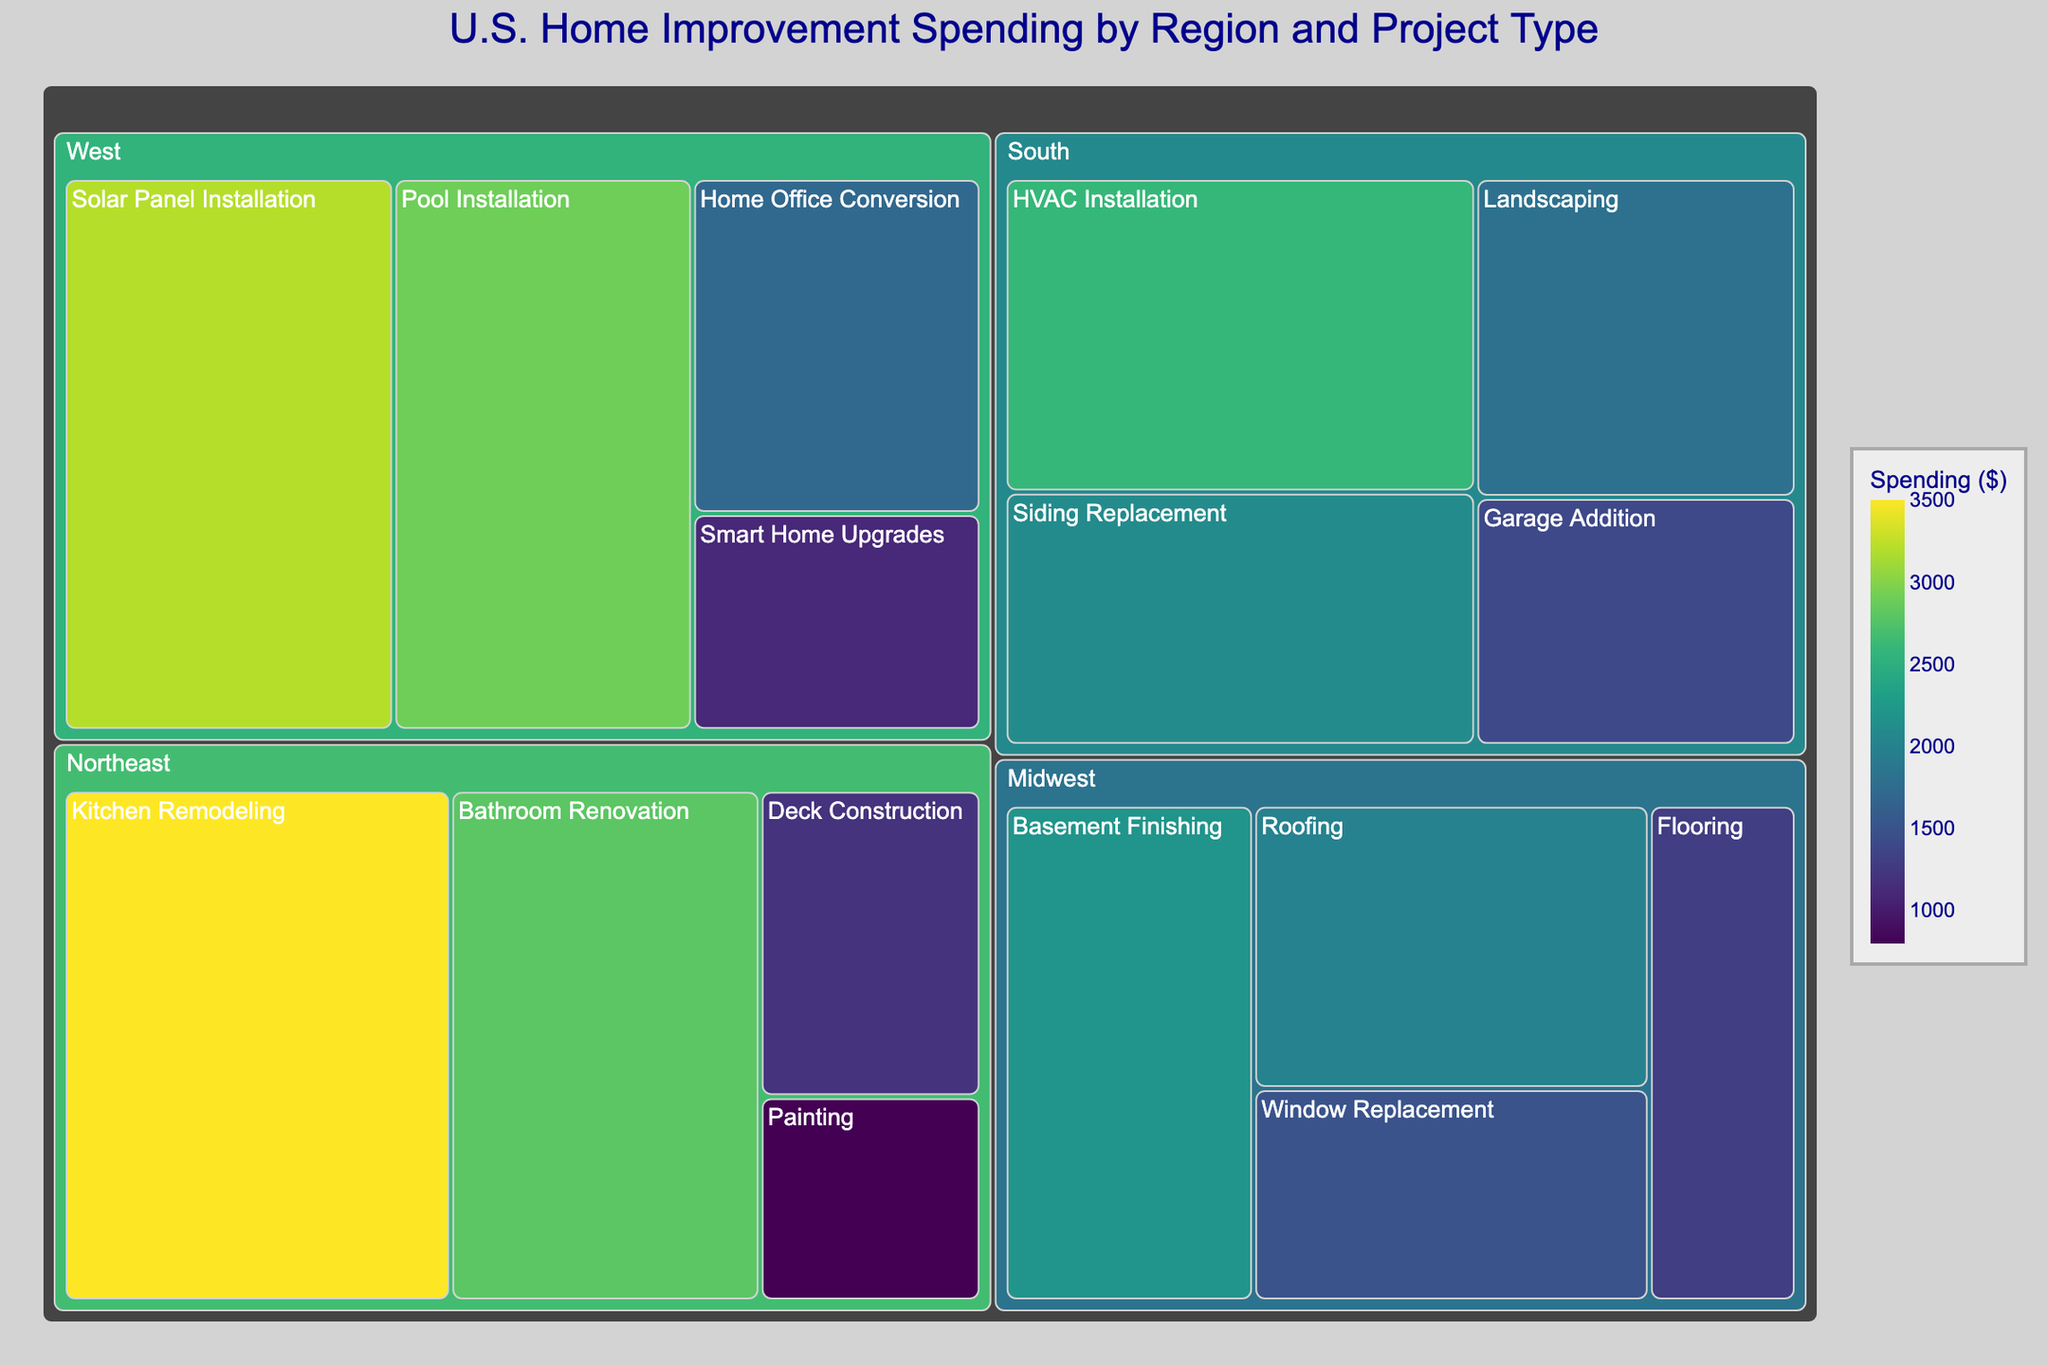What is the total spending on Kitchen Remodeling in the Northeast? According to the figure, the spending on Kitchen Remodeling in the Northeast is represented with specific monetary value. Find that value in the treemap.
Answer: $3500 Which region has the highest spending on Solar Panel Installation? The treemap indicates the spending by region and project type. Locate the region where Solar Panel Installation spending is highest.
Answer: West Which project type has the lowest spending in the Northeast? Check the different project types within the Northeast region in the treemap and identify the one with the smallest value.
Answer: Painting What is the combined spending on Roofing and Siding Replacement in the South? Find the spending on Roofing and Siding Replacement in the South by looking at their respective values in the treemap. Add these two values together.
Answer: $4100 In which region is the spending on Home Office Conversion higher, the South or the West? Locate the spending on Home Office Conversion for both the South and the West. Compare their values.
Answer: West What is the total spending for the Midwest region across all project types? Sum up all the spending numbers for different project types listed under the Midwest region in the treemap.
Answer: $7000 Which has a greater spending amount: Kitchen Remodeling in the Northeast or HVAC Installation in the South? Compare the spending values for Kitchen Remodeling in the Northeast and HVAC Installation in the South found in the treemap.
Answer: Kitchen Remodeling in the Northeast How does the spending on Pool Installation in the West compare to Bathroom Renovation in the Northeast? Locate the spending on Pool Installation in the West and Bathroom Renovation in the Northeast. Evaluate which is higher.
Answer: Pool Installation in the West What is the average spending on Deck Construction and Painting in the Northeast? Identify the spending values for Deck Construction and Painting in the Northeast. Add these values and divide by 2 to get the average.
Answer: $1000 Which region has the smallest total spending across all project types? Sum the spending values for each region and determine which region has the smallest total.
Answer: Midwest 